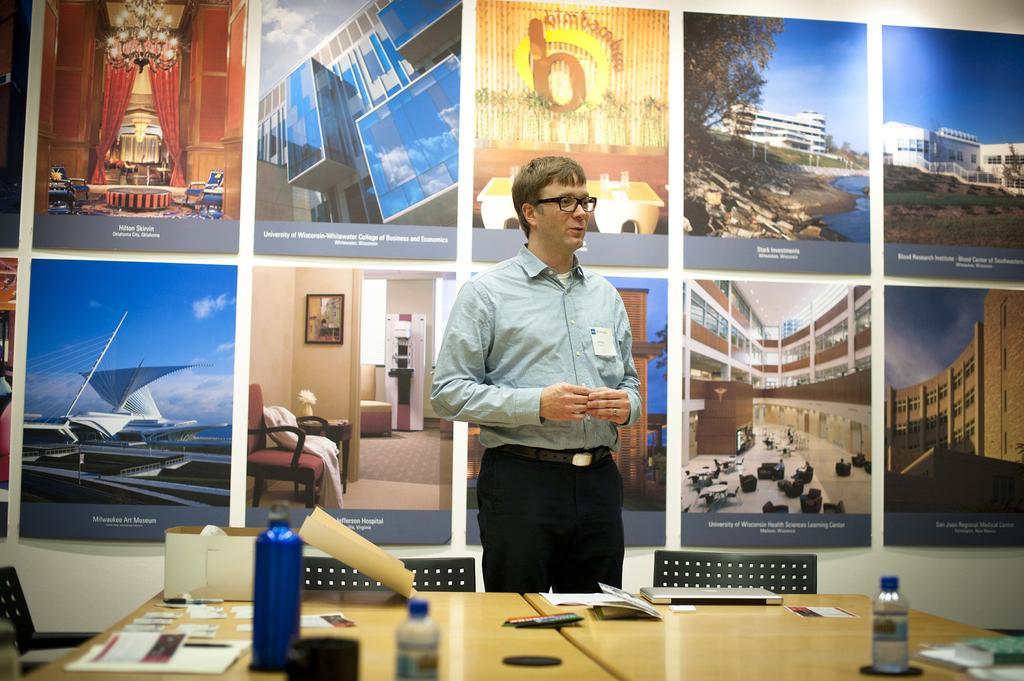Describe this image in one or two sentences. There is a person standing in the foreground area of the image, there are chairs and a table at the bottom side, there are papers, bottles, laptop and other items on the table, it seems like a screen in the background, on which there are posters. 